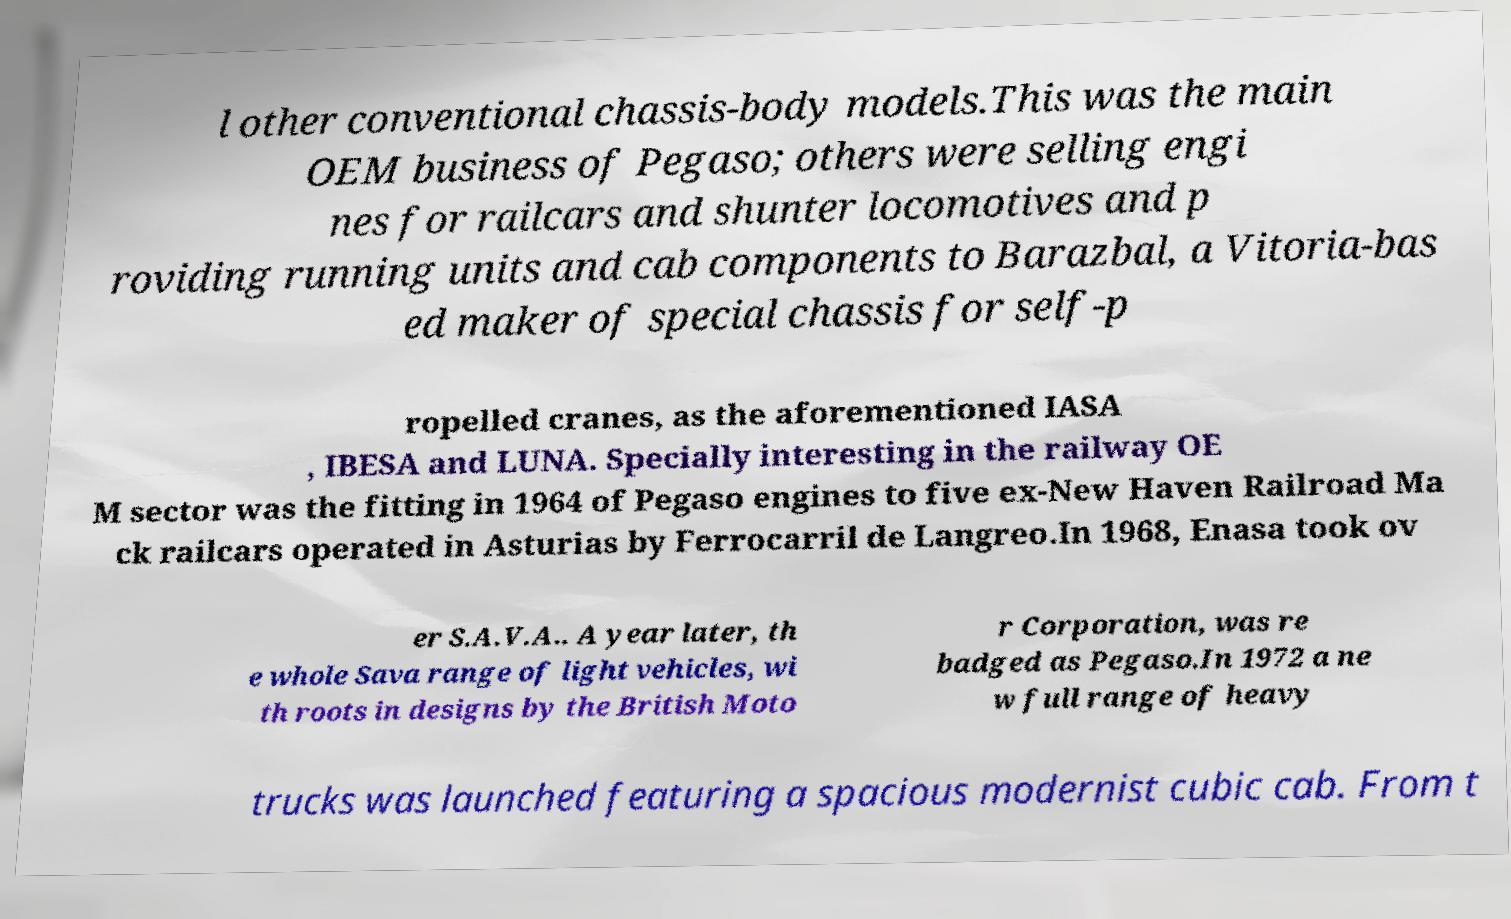What messages or text are displayed in this image? I need them in a readable, typed format. l other conventional chassis-body models.This was the main OEM business of Pegaso; others were selling engi nes for railcars and shunter locomotives and p roviding running units and cab components to Barazbal, a Vitoria-bas ed maker of special chassis for self-p ropelled cranes, as the aforementioned IASA , IBESA and LUNA. Specially interesting in the railway OE M sector was the fitting in 1964 of Pegaso engines to five ex-New Haven Railroad Ma ck railcars operated in Asturias by Ferrocarril de Langreo.In 1968, Enasa took ov er S.A.V.A.. A year later, th e whole Sava range of light vehicles, wi th roots in designs by the British Moto r Corporation, was re badged as Pegaso.In 1972 a ne w full range of heavy trucks was launched featuring a spacious modernist cubic cab. From t 